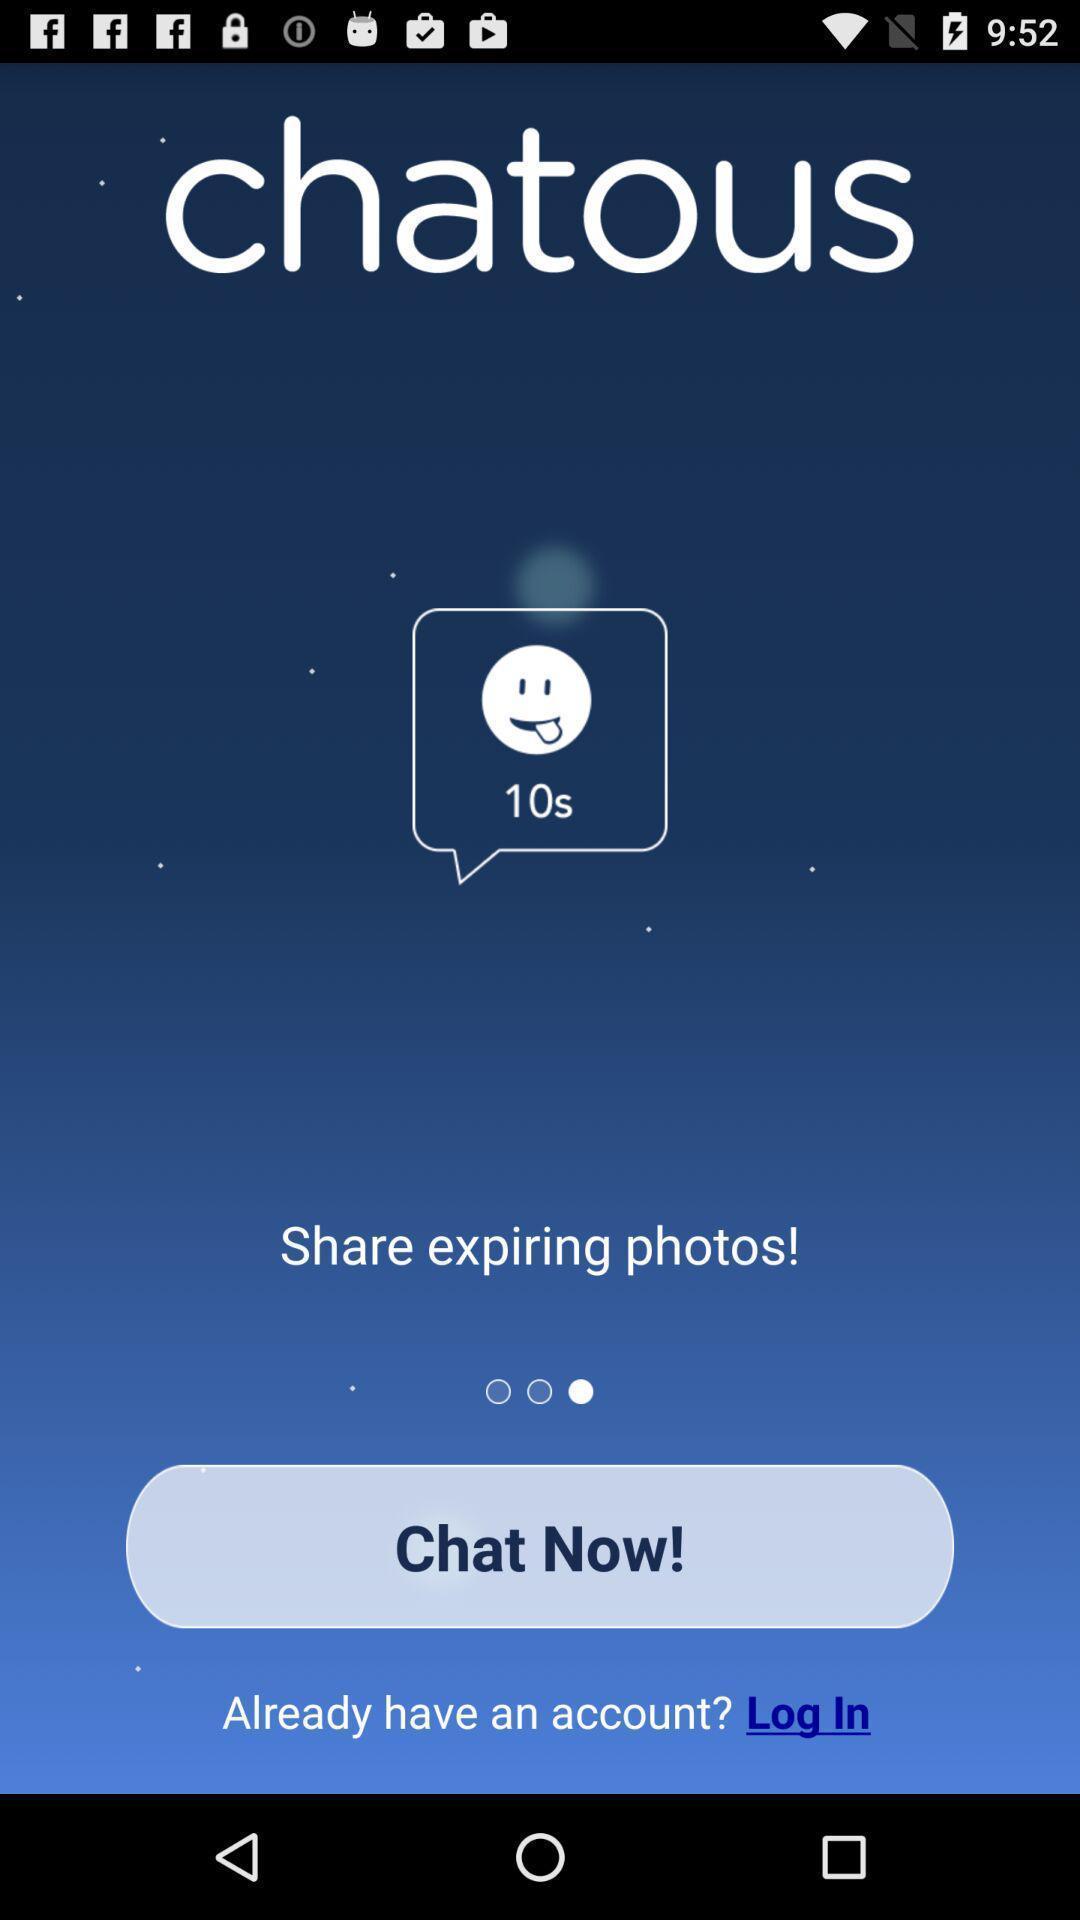Tell me what you see in this picture. Welcome page of a social application. 